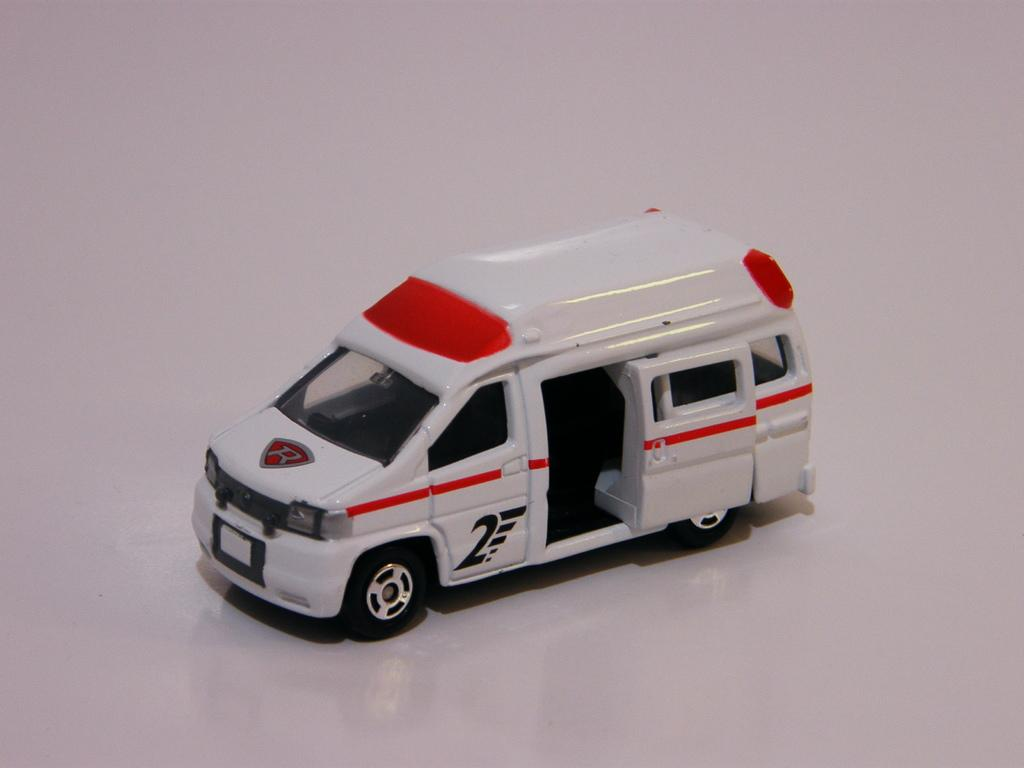What is the main subject of the picture? The main subject of the picture is a toy vehicle. Where is the toy vehicle located in the image? The toy vehicle is on a floor. Can you describe any additional features of the toy vehicle in the image? There is a reflection of the vehicle on the floor. How many women are present in the image? There are no women present in the image; it features a toy vehicle on a floor. What type of butter is being used to grease the toy vehicle in the image? There is no butter present in the image, nor is there any indication that the toy vehicle is being greased. 